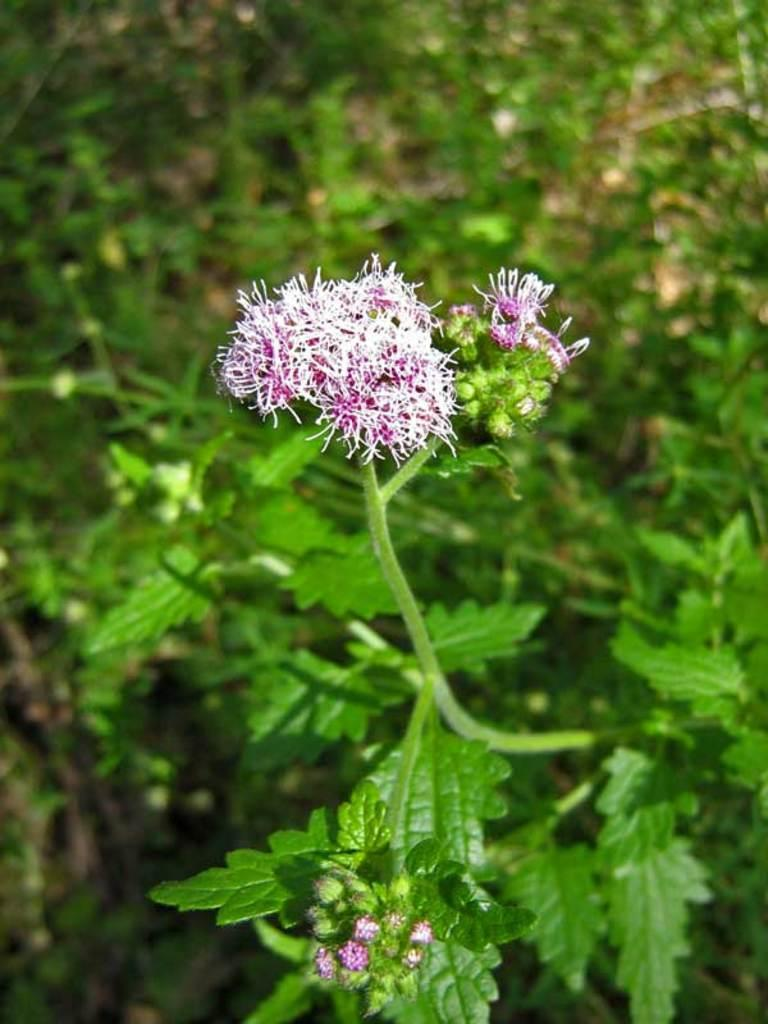What is the main subject of the image? There is a flower in the image. Can you describe the setting of the image? In the background of the image, there are plants. How many grapes are hanging from the flower in the image? There are no grapes present in the image; it features a flower and plants in the background. 